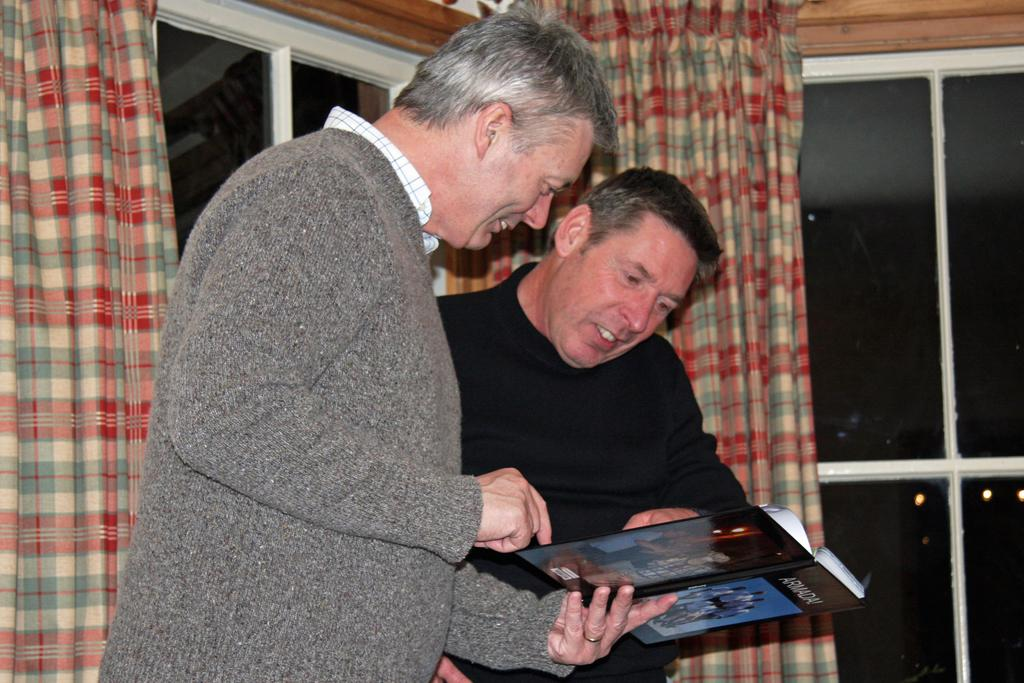How many people are present in the image? There are two people in the image. Can you describe the clothing of the people in the image? The people are wearing different color dresses. What is one person doing in the image? One person is holding an object. What can be seen in the background of the image? There are curtains visible in the background. What are the curtains associated with? The curtains are associated with windows. What type of operation is being performed on the pizzas in the image? There are no pizzas present in the image, so no operation can be observed. 